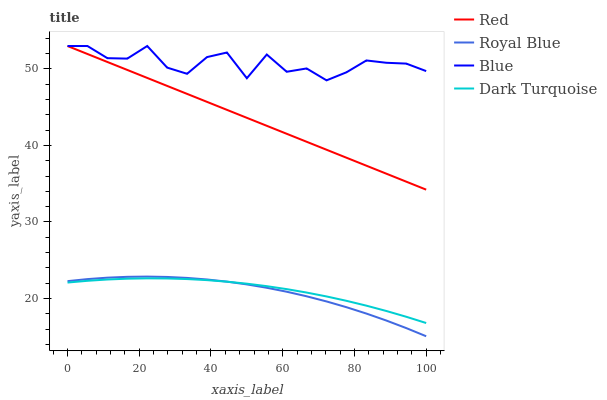Does Royal Blue have the minimum area under the curve?
Answer yes or no. Yes. Does Blue have the maximum area under the curve?
Answer yes or no. Yes. Does Red have the minimum area under the curve?
Answer yes or no. No. Does Red have the maximum area under the curve?
Answer yes or no. No. Is Red the smoothest?
Answer yes or no. Yes. Is Blue the roughest?
Answer yes or no. Yes. Is Royal Blue the smoothest?
Answer yes or no. No. Is Royal Blue the roughest?
Answer yes or no. No. Does Royal Blue have the lowest value?
Answer yes or no. Yes. Does Red have the lowest value?
Answer yes or no. No. Does Red have the highest value?
Answer yes or no. Yes. Does Royal Blue have the highest value?
Answer yes or no. No. Is Dark Turquoise less than Red?
Answer yes or no. Yes. Is Red greater than Royal Blue?
Answer yes or no. Yes. Does Red intersect Blue?
Answer yes or no. Yes. Is Red less than Blue?
Answer yes or no. No. Is Red greater than Blue?
Answer yes or no. No. Does Dark Turquoise intersect Red?
Answer yes or no. No. 